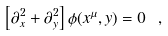Convert formula to latex. <formula><loc_0><loc_0><loc_500><loc_500>\left [ \partial ^ { 2 } _ { x } + \partial ^ { 2 } _ { y } \right ] \phi ( x ^ { \mu } , y ) = 0 \ ,</formula> 